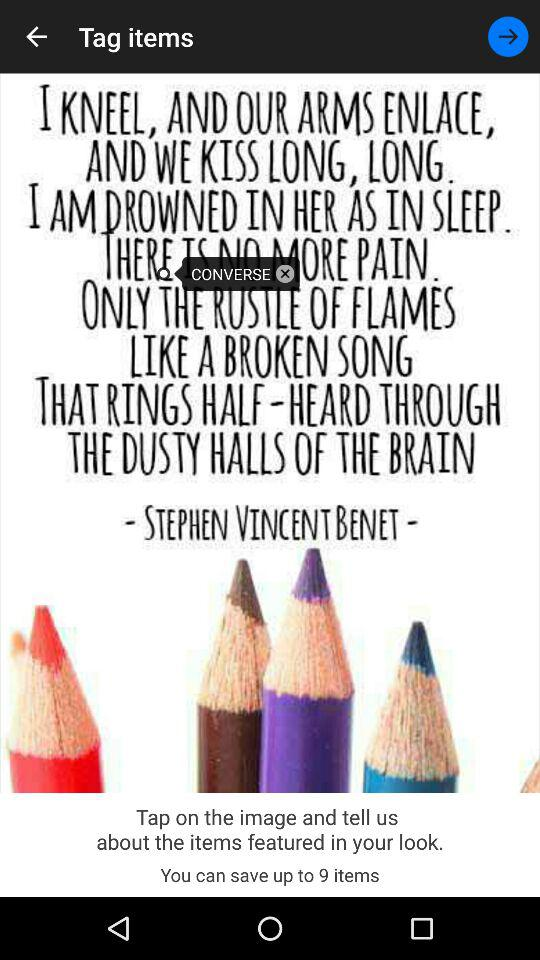How many items can I save in the look?
Answer the question using a single word or phrase. 9 